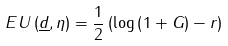<formula> <loc_0><loc_0><loc_500><loc_500>E U \left ( \underline { d } , \eta \right ) = \frac { 1 } { 2 } \left ( \log \left ( 1 + G \right ) - r \right )</formula> 